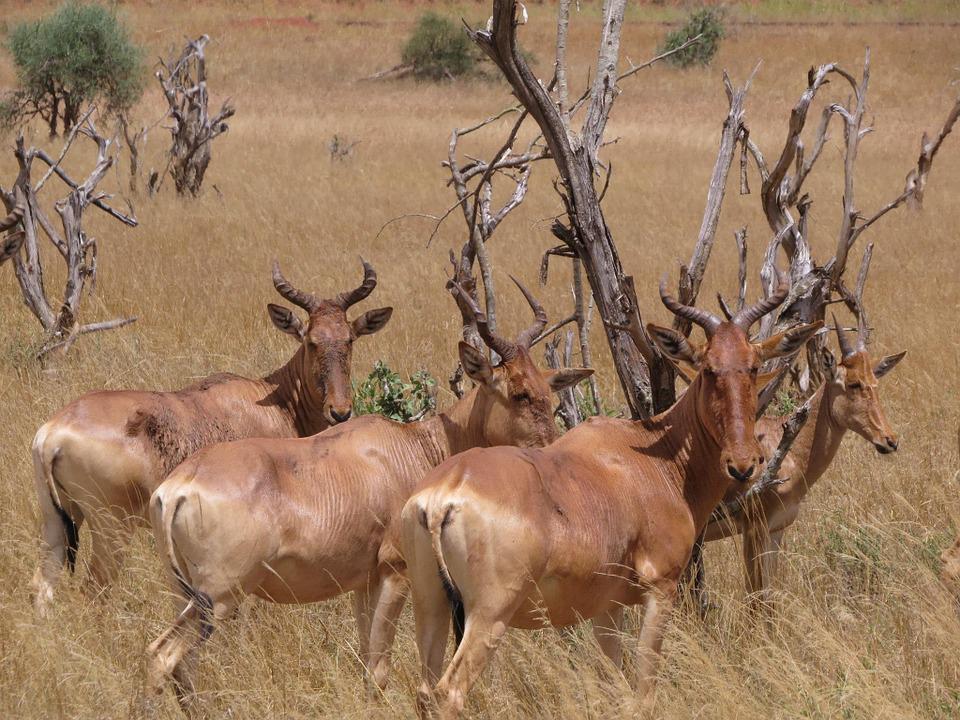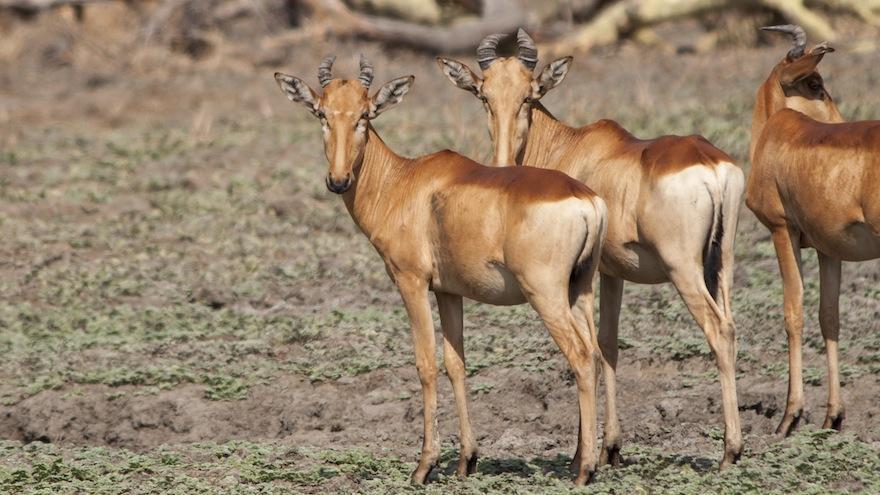The first image is the image on the left, the second image is the image on the right. For the images displayed, is the sentence "There are three animals." factually correct? Answer yes or no. No. 